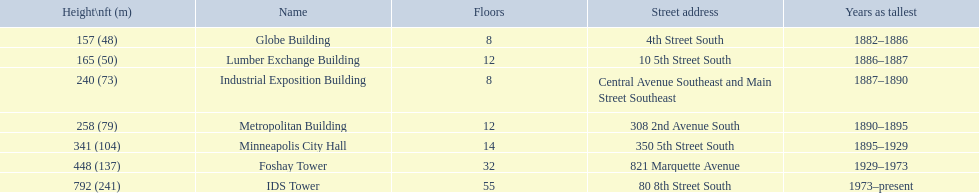Parse the full table. {'header': ['Height\\nft (m)', 'Name', 'Floors', 'Street address', 'Years as tallest'], 'rows': [['157 (48)', 'Globe Building', '8', '4th Street South', '1882–1886'], ['165 (50)', 'Lumber Exchange Building', '12', '10 5th Street South', '1886–1887'], ['240 (73)', 'Industrial Exposition Building', '8', 'Central Avenue Southeast and Main Street Southeast', '1887–1890'], ['258 (79)', 'Metropolitan Building', '12', '308 2nd Avenue South', '1890–1895'], ['341 (104)', 'Minneapolis City Hall', '14', '350 5th Street South', '1895–1929'], ['448 (137)', 'Foshay Tower', '32', '821 Marquette Avenue', '1929–1973'], ['792 (241)', 'IDS Tower', '55', '80 8th Street South', '1973–present']]} Which building has the same number of floors as the lumber exchange building? Metropolitan Building. 